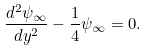Convert formula to latex. <formula><loc_0><loc_0><loc_500><loc_500>\frac { d ^ { 2 } \psi _ { \infty } } { d y ^ { 2 } } - \frac { 1 } { 4 } \psi _ { \infty } = 0 .</formula> 